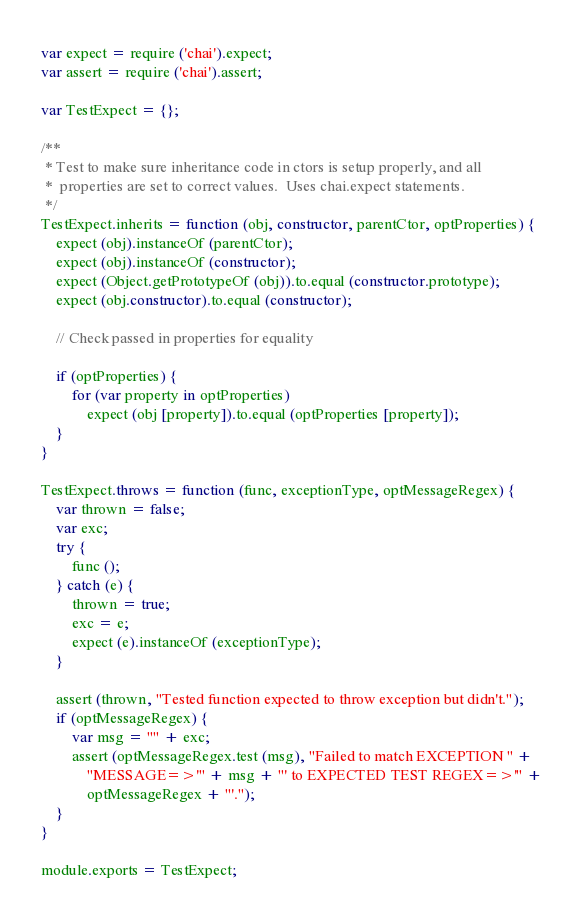<code> <loc_0><loc_0><loc_500><loc_500><_JavaScript_>
var expect = require ('chai').expect;
var assert = require ('chai').assert;

var TestExpect = {};

/**
 * Test to make sure inheritance code in ctors is setup properly, and all
 *  properties are set to correct values.  Uses chai.expect statements.
 */
TestExpect.inherits = function (obj, constructor, parentCtor, optProperties) {
    expect (obj).instanceOf (parentCtor);
    expect (obj).instanceOf (constructor);
    expect (Object.getPrototypeOf (obj)).to.equal (constructor.prototype);
    expect (obj.constructor).to.equal (constructor);

    // Check passed in properties for equality

    if (optProperties) {
        for (var property in optProperties)
            expect (obj [property]).to.equal (optProperties [property]);
    }
}

TestExpect.throws = function (func, exceptionType, optMessageRegex) {
    var thrown = false;
    var exc;
    try {
        func ();
    } catch (e) {
        thrown = true;
        exc = e;
        expect (e).instanceOf (exceptionType);
    }

    assert (thrown, "Tested function expected to throw exception but didn't.");
    if (optMessageRegex) {
        var msg = "" + exc;
        assert (optMessageRegex.test (msg), "Failed to match EXCEPTION " +
            "MESSAGE=>'" + msg + "' to EXPECTED TEST REGEX=>'" +
            optMessageRegex + "'.");
    }
}

module.exports = TestExpect;
</code> 